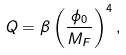<formula> <loc_0><loc_0><loc_500><loc_500>Q = \beta \left ( \frac { \phi _ { 0 } } { M _ { F } } \right ) ^ { 4 } ,</formula> 